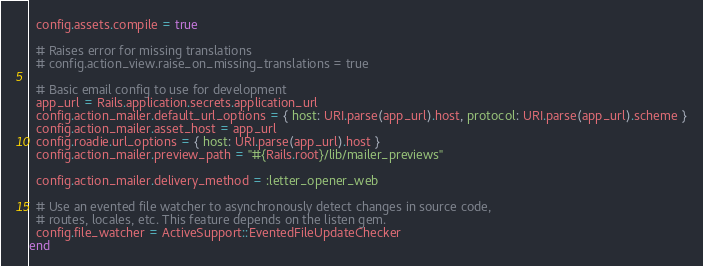<code> <loc_0><loc_0><loc_500><loc_500><_Ruby_>  config.assets.compile = true

  # Raises error for missing translations
  # config.action_view.raise_on_missing_translations = true

  # Basic email config to use for development
  app_url = Rails.application.secrets.application_url
  config.action_mailer.default_url_options = { host: URI.parse(app_url).host, protocol: URI.parse(app_url).scheme }
  config.action_mailer.asset_host = app_url
  config.roadie.url_options = { host: URI.parse(app_url).host }
  config.action_mailer.preview_path = "#{Rails.root}/lib/mailer_previews"

  config.action_mailer.delivery_method = :letter_opener_web

  # Use an evented file watcher to asynchronously detect changes in source code,
  # routes, locales, etc. This feature depends on the listen gem.
  config.file_watcher = ActiveSupport::EventedFileUpdateChecker
end
</code> 